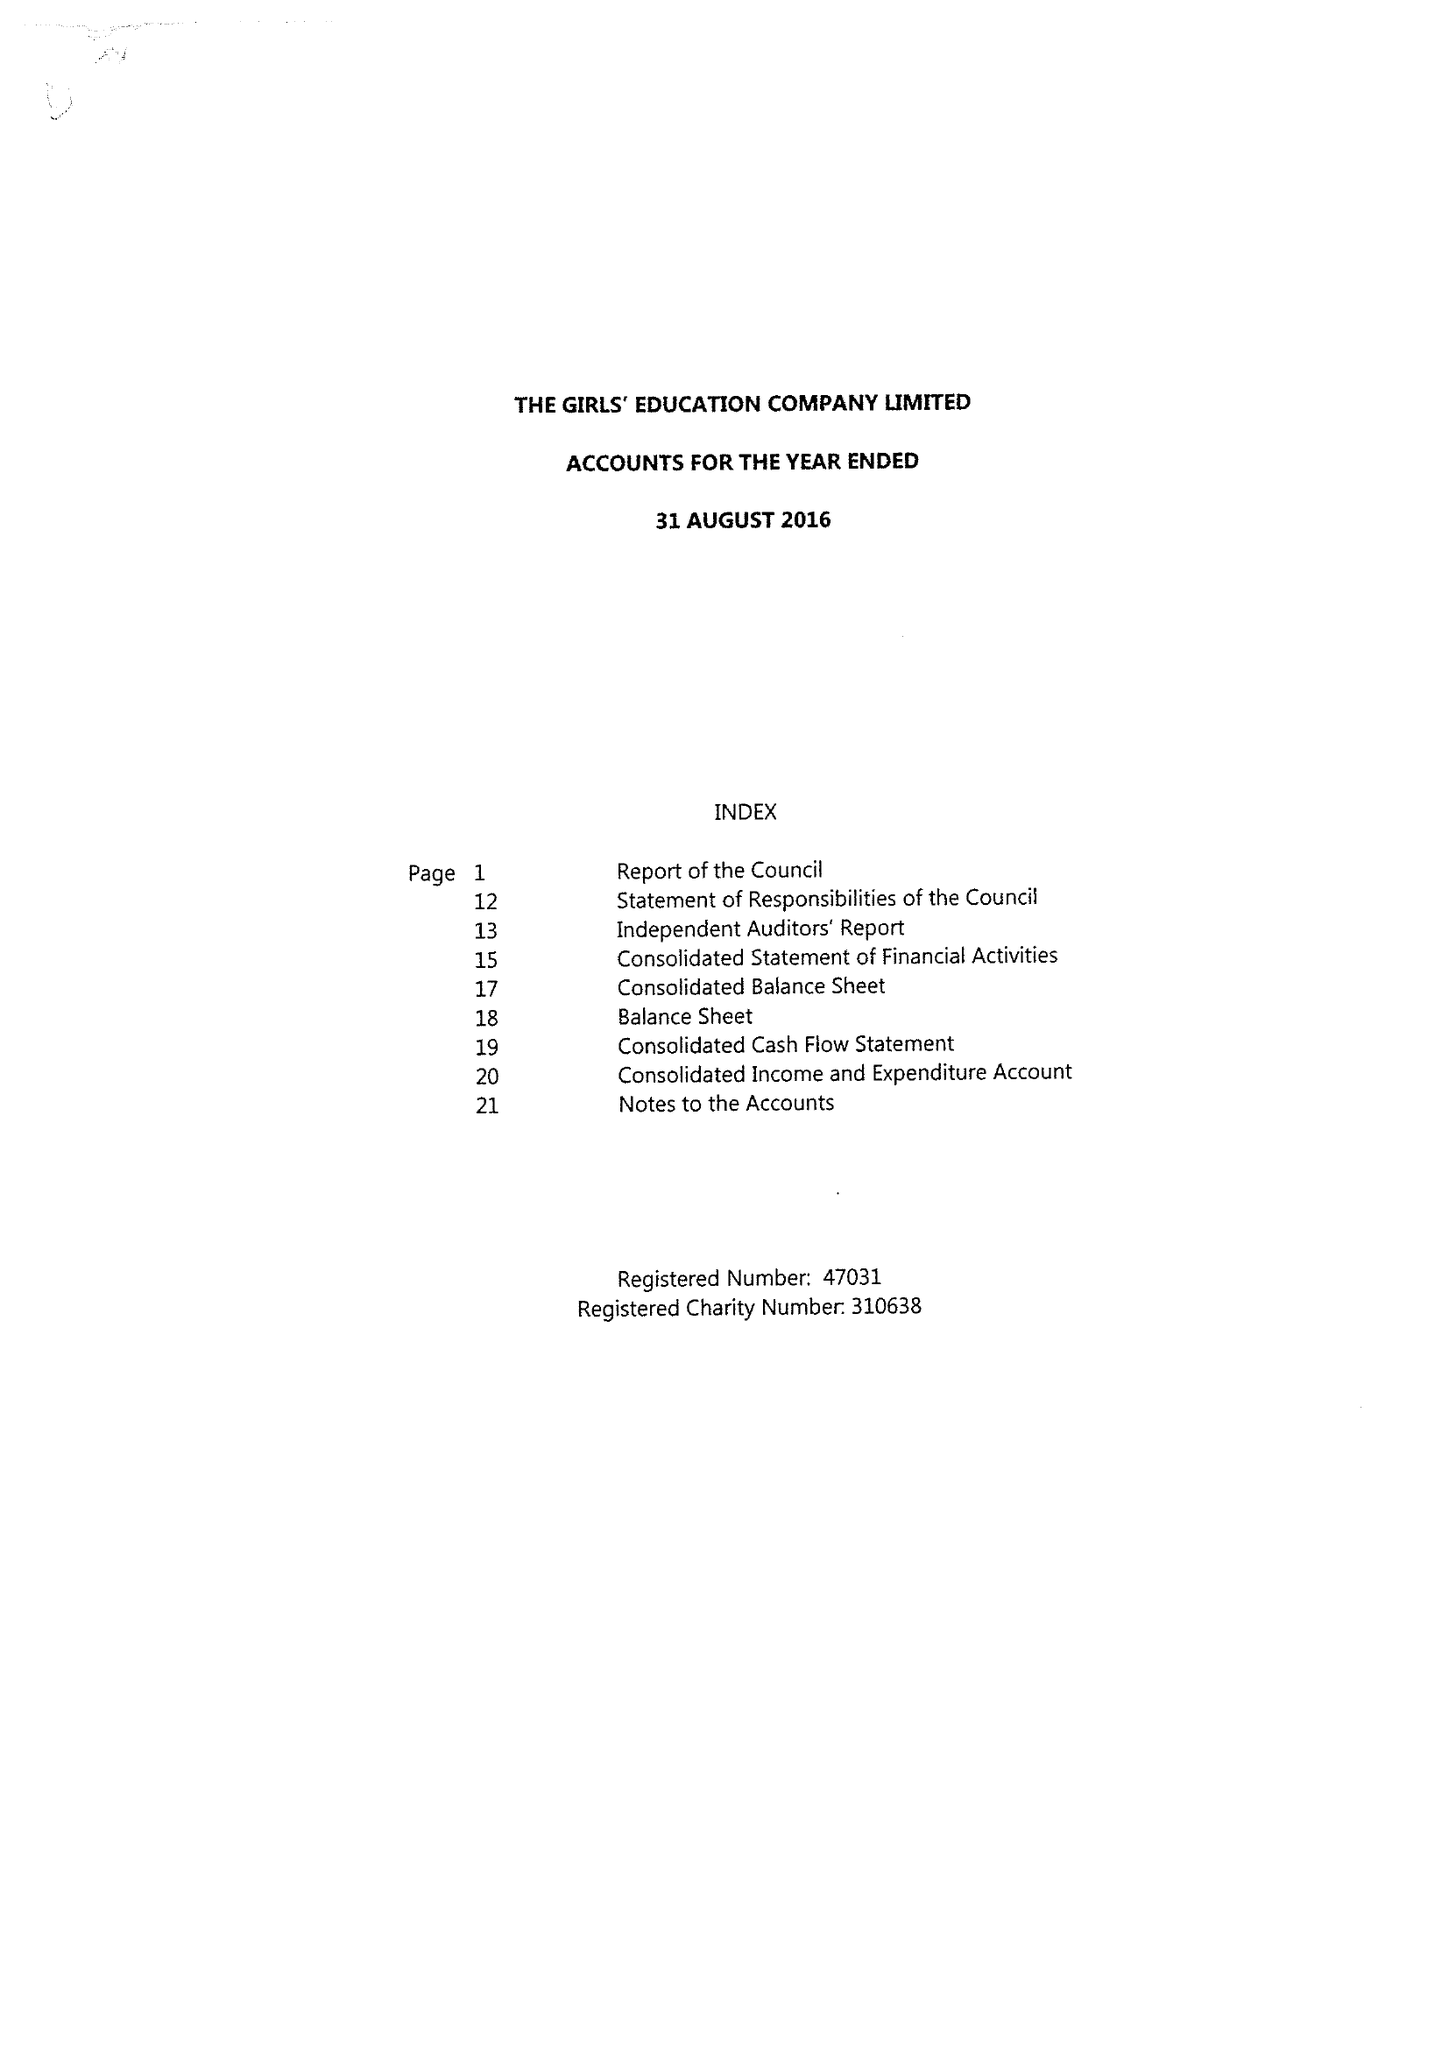What is the value for the spending_annually_in_british_pounds?
Answer the question using a single word or phrase. 19396580.00 